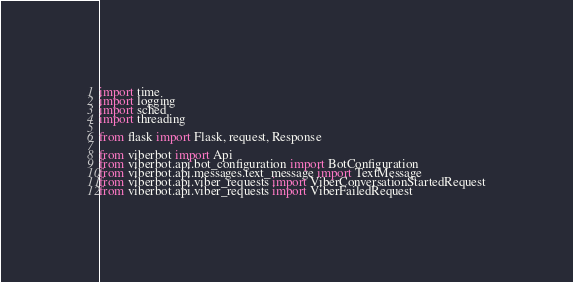Convert code to text. <code><loc_0><loc_0><loc_500><loc_500><_Python_>import time
import logging
import sched
import threading

from flask import Flask, request, Response

from viberbot import Api
from viberbot.api.bot_configuration import BotConfiguration
from viberbot.api.messages.text_message import TextMessage
from viberbot.api.viber_requests import ViberConversationStartedRequest
from viberbot.api.viber_requests import ViberFailedRequest</code> 